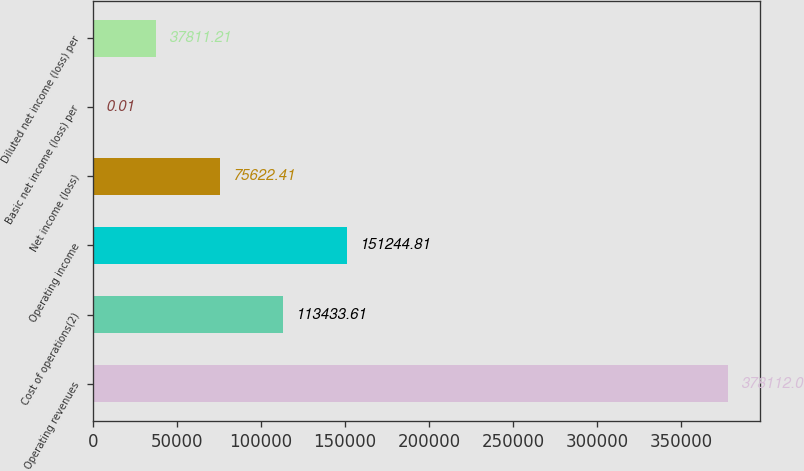Convert chart to OTSL. <chart><loc_0><loc_0><loc_500><loc_500><bar_chart><fcel>Operating revenues<fcel>Cost of operations(2)<fcel>Operating income<fcel>Net income (loss)<fcel>Basic net income (loss) per<fcel>Diluted net income (loss) per<nl><fcel>378112<fcel>113434<fcel>151245<fcel>75622.4<fcel>0.01<fcel>37811.2<nl></chart> 